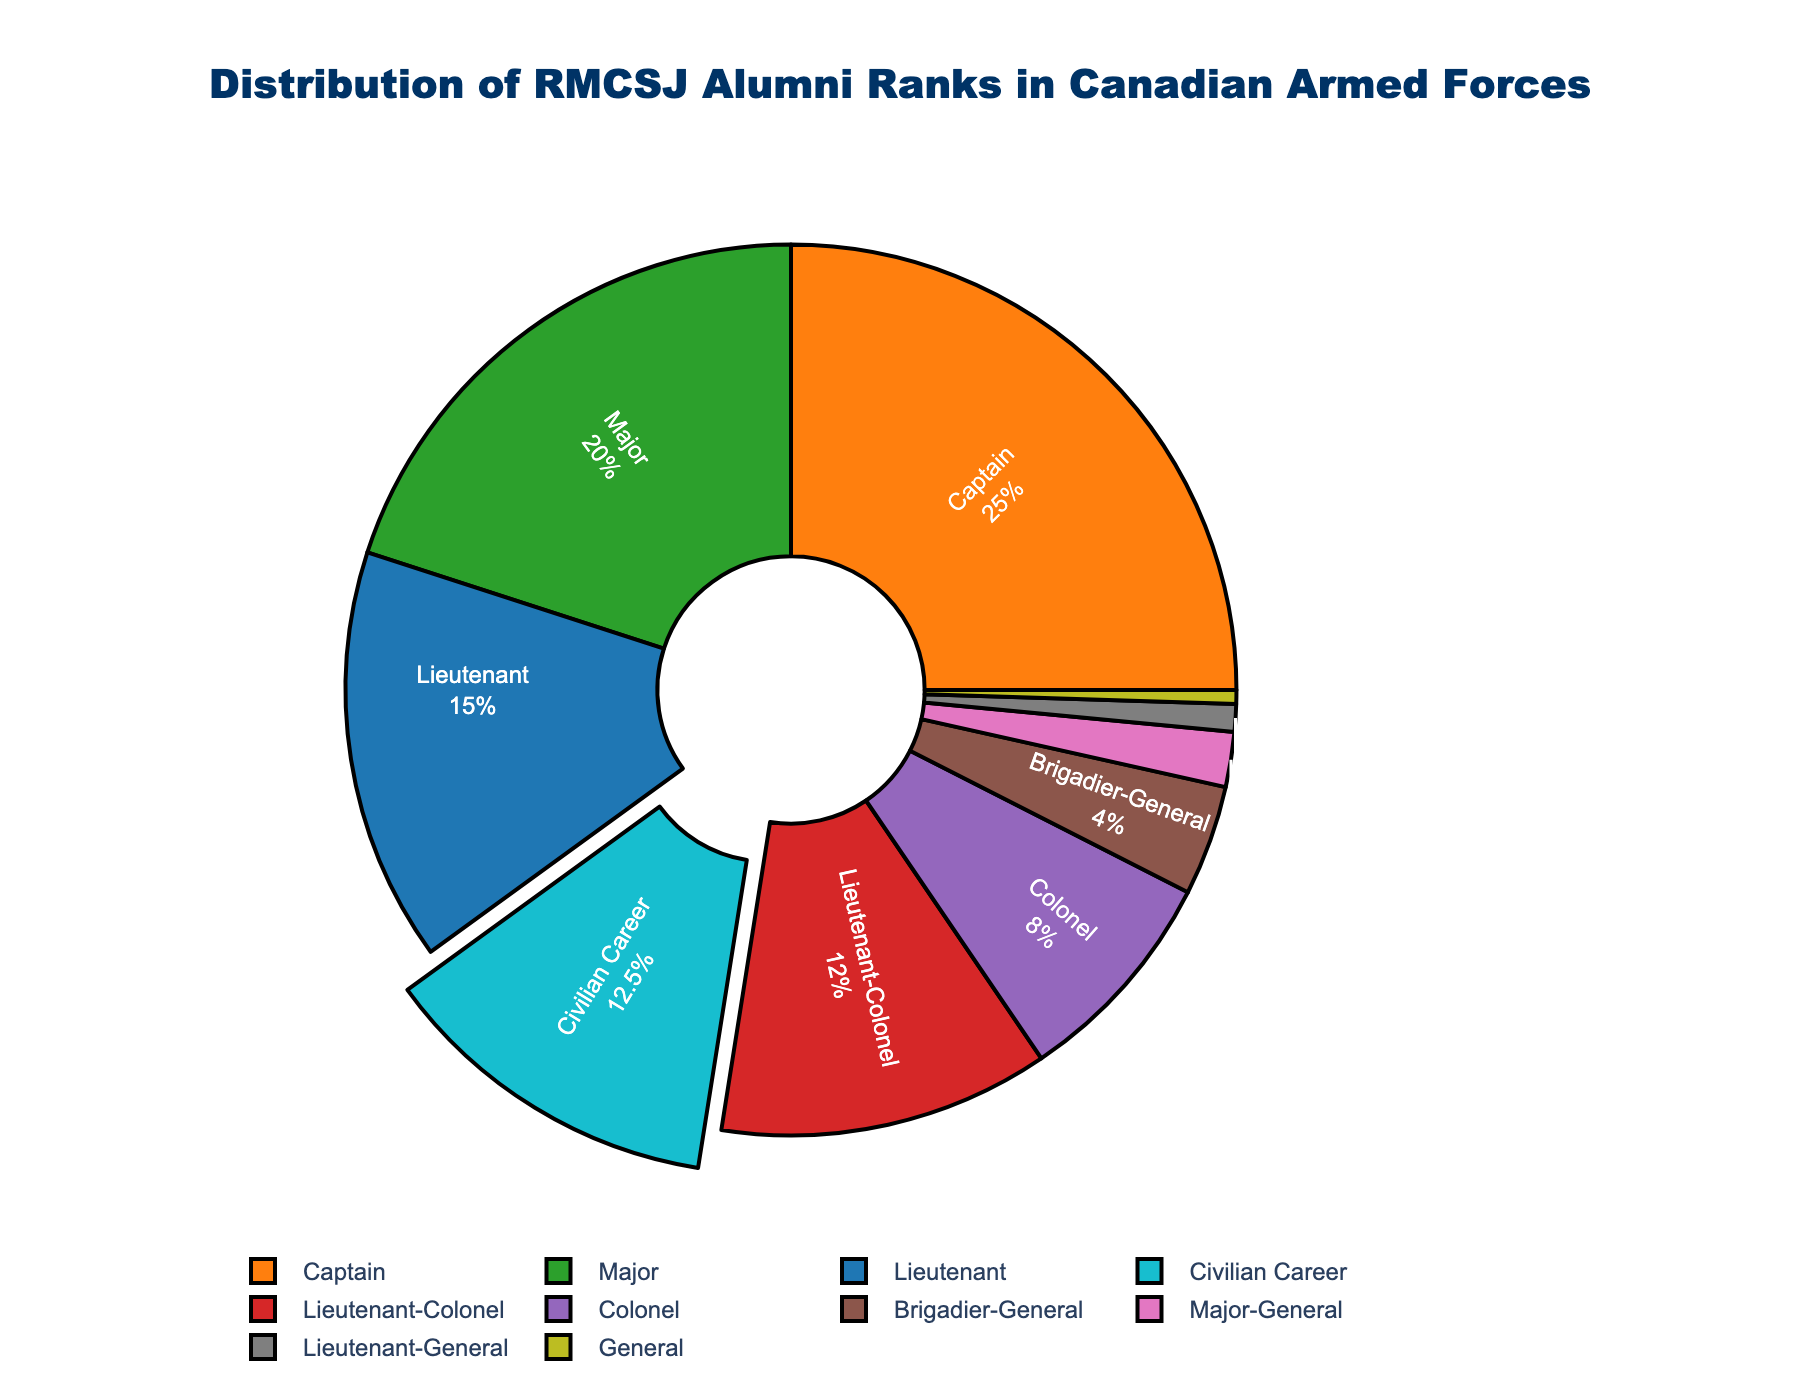What percentage of RMCSJ alumni hold the rank of Major? From the figure, locate the segment labeled 'Major' and refer to its associated percentage value.
Answer: 20 Which rank has a higher percentage of RMCSJ alumni: Colonel or Lieutenant-Colonel? Compare the percentage values associated with the ranks 'Colonel' and 'Lieutenant-Colonel' from the chart.
Answer: Lieutenant-Colonel What is the combined percentage of RMCSJ alumni holding the top three ranks in the Canadian Armed Forces? Identify the top three ranks as 'General', 'Lieutenant-General', and 'Major-General'. Sum their respective percentages (0.5% + 1% + 2%).
Answer: 3.5 How many RMCSJ alumni are either holding the rank of Captain or pursuing a civilian career, percentage-wise? Locate the percentage values for 'Captain' and 'Civilian Career'. Add the two percentages (25% + 12.5%).
Answer: 37.5 Is the percentage of RMCSJ alumni who are Captains greater than the combined percentage of those who are Lieutenants and Colonels? Compare the percentage for 'Captain' to the sum of 'Lieutenant' and 'Colonel' (25% vs. 15% + 8% = 23%).
Answer: Yes Which color represents the rank of Brigadier-General? Identify the segment labeled 'Brigadier-General' and describe its color based on the visual attributes of the figure.
Answer: Pink How does the percentage of RMCSJ alumni who are Majors compare to those pursuing civilian careers? Compare the percentage value of 'Major' with 'Civilian Career'.
Answer: Major is higher By what percentage do RMCSJ alumni in the rank of Captain outnumber those in the rank of Major? Find the difference between the percentages of 'Captain' and 'Major' (25% - 20%).
Answer: 5 